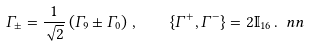<formula> <loc_0><loc_0><loc_500><loc_500>\Gamma _ { \pm } = \frac { 1 } { \sqrt { 2 } } \left ( \Gamma _ { 9 } \pm \Gamma _ { 0 } \right ) \, , \quad \{ \Gamma ^ { + } , \Gamma ^ { - } \} = 2 \mathbb { I } _ { 1 6 } \, . \ n n</formula> 